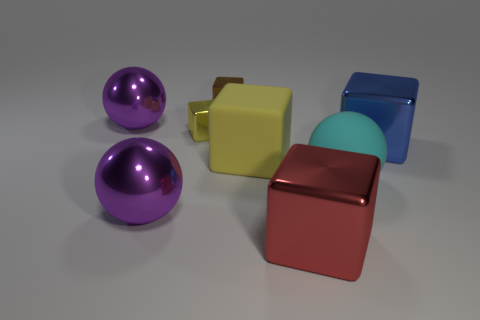Are the large blue cube and the tiny yellow thing made of the same material?
Your answer should be compact. Yes. What number of spheres are either tiny yellow metallic objects or large blue things?
Keep it short and to the point. 0. There is a matte object behind the big matte ball; what color is it?
Your answer should be very brief. Yellow. How many matte things are tiny yellow things or cylinders?
Your response must be concise. 0. What is the material of the large purple ball in front of the large metallic block that is behind the large red thing?
Provide a short and direct response. Metal. There is a thing that is the same color as the rubber cube; what is its material?
Your response must be concise. Metal. The big rubber ball has what color?
Provide a succinct answer. Cyan. Is there a large blue shiny object behind the purple thing that is in front of the blue shiny block?
Give a very brief answer. Yes. What material is the large blue object?
Your answer should be compact. Metal. Does the large purple sphere behind the large cyan matte sphere have the same material as the small block that is to the left of the tiny brown object?
Your answer should be very brief. Yes. 